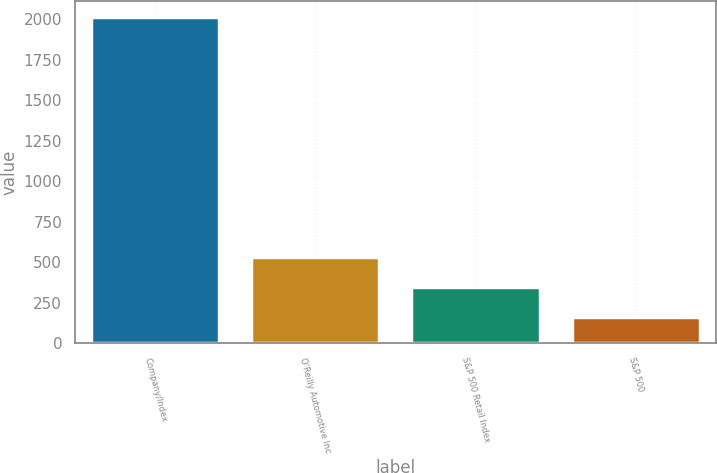Convert chart. <chart><loc_0><loc_0><loc_500><loc_500><bar_chart><fcel>Company/Index<fcel>O'Reilly Automotive Inc<fcel>S&P 500 Retail Index<fcel>S&P 500<nl><fcel>2014<fcel>534<fcel>349<fcel>164<nl></chart> 